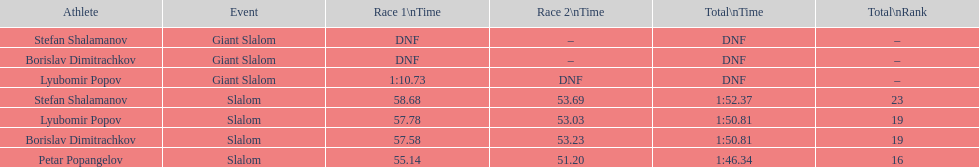How many athletes are there total? 4. 